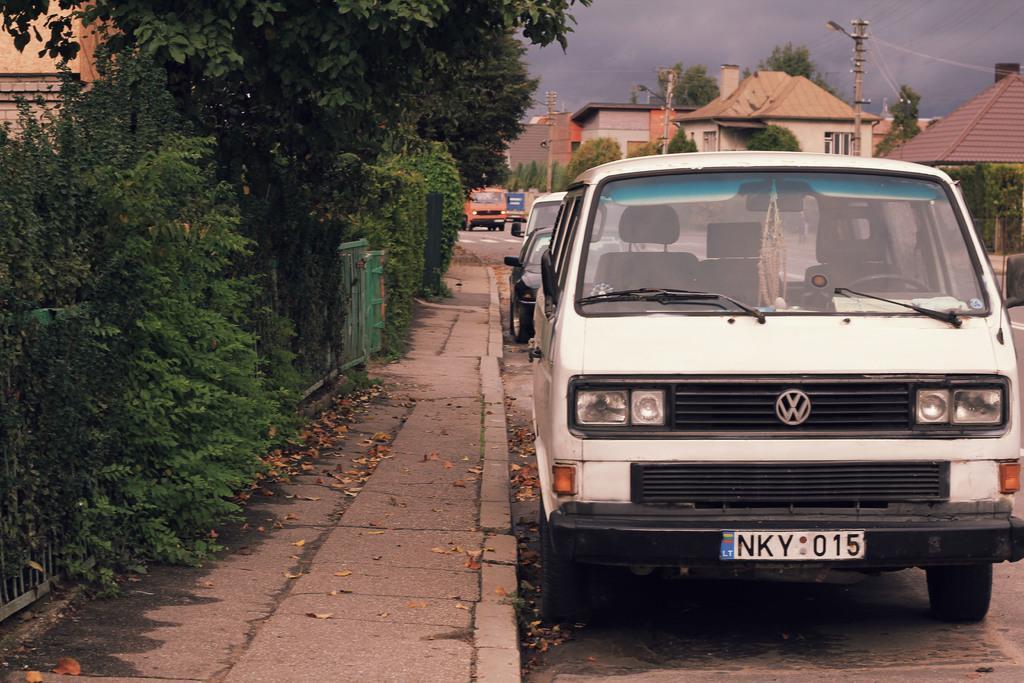How would you summarize this image in a sentence or two? In this image I can see few vehicles, few buildings, few poles, few street lights, the sky and few trees. I can also see something is written over here. 